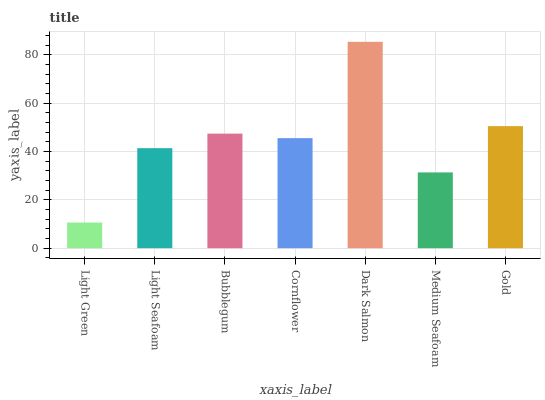Is Light Green the minimum?
Answer yes or no. Yes. Is Dark Salmon the maximum?
Answer yes or no. Yes. Is Light Seafoam the minimum?
Answer yes or no. No. Is Light Seafoam the maximum?
Answer yes or no. No. Is Light Seafoam greater than Light Green?
Answer yes or no. Yes. Is Light Green less than Light Seafoam?
Answer yes or no. Yes. Is Light Green greater than Light Seafoam?
Answer yes or no. No. Is Light Seafoam less than Light Green?
Answer yes or no. No. Is Cornflower the high median?
Answer yes or no. Yes. Is Cornflower the low median?
Answer yes or no. Yes. Is Light Green the high median?
Answer yes or no. No. Is Gold the low median?
Answer yes or no. No. 